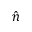<formula> <loc_0><loc_0><loc_500><loc_500>\hat { n }</formula> 